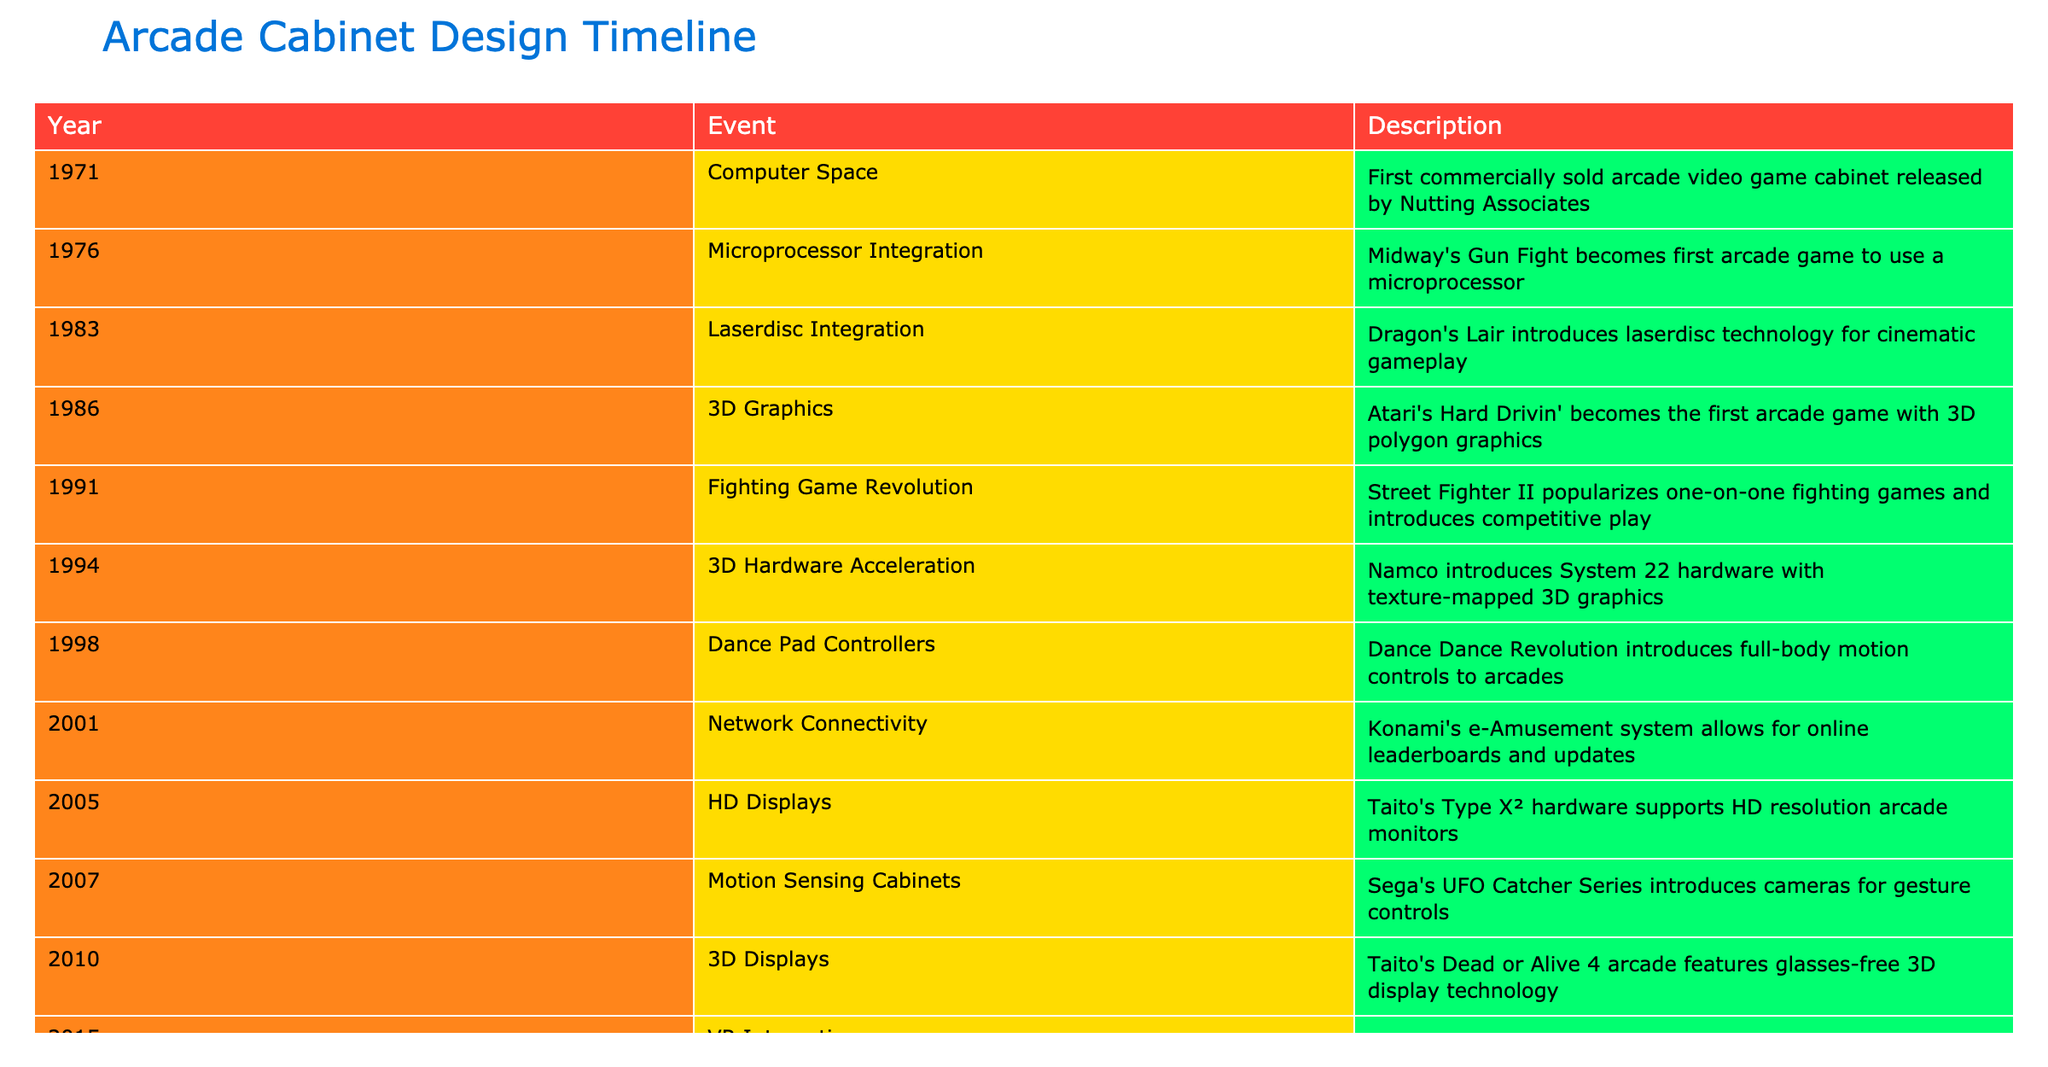What year did Dragon's Lair introduce laserdisc technology? According to the table, Dragon's Lair introduced laserdisc technology in 1983.
Answer: 1983 Which event marks the introduction of HD displays in arcade cabinets? The introduction of HD displays in arcade cabinets is marked by Taito's Type X² hardware in 2005.
Answer: 2005 Was the first arcade game to use a microprocessor released before 1980? The first arcade game to use a microprocessor, which is Midway's Gun Fight, was released in 1976, hence it was released before 1980.
Answer: Yes How many years passed between the introduction of motion-sensing cabinets and virtual reality in arcade cabinets? Motion-sensing cabinets were introduced in 2007 and virtual reality was introduced in 2015. The difference is calculated as 2015 - 2007 = 8 years.
Answer: 8 years Which arcade cabinet introduced full-body motion controls and in what year? Dance Dance Revolution introduced full-body motion controls in 1998 as indicated in the table.
Answer: Dance Dance Revolution, 1998 What technological advancement occurred in the year after Street Fighter II was released? Street Fighter II was released in 1991, and in 1994, 3D hardware acceleration was introduced with Namco’s System 22 hardware.
Answer: 3D hardware acceleration in 1994 How many events listed in the table involved the integration of new input methods (such as controllers or displays)? The events are: Dance Dance Revolution (1998 - dance pad controllers), motion sensing cabinets (2007), touchscreen integration (2018), and contactless controls (2020). This totals to 4 events.
Answer: 4 events Is the introduction of cloud gaming cabinets the most recent event in the table? Yes, the introduction of cloud gaming cabinets by Arcade1Up occurred in 2022, which is the most recent event in the table.
Answer: Yes What was the first arcade game with 3D polygon graphics and in what year was it released? The first arcade game with 3D polygon graphics was Atari's Hard Drivin', which was released in 1986.
Answer: Atari's Hard Drivin', 1986 